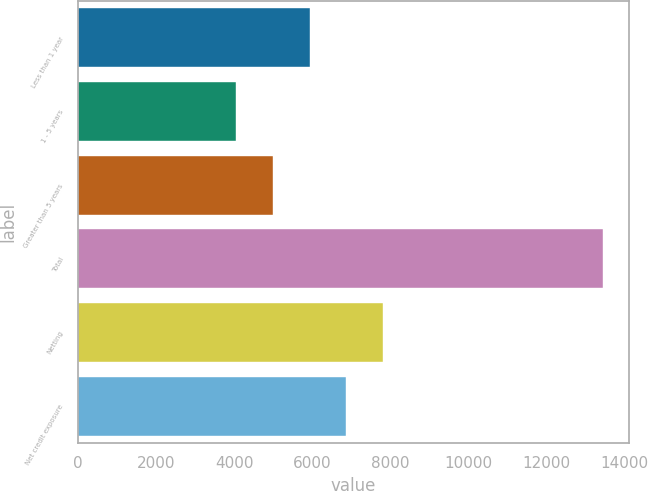Convert chart. <chart><loc_0><loc_0><loc_500><loc_500><bar_chart><fcel>Less than 1 year<fcel>1 - 5 years<fcel>Greater than 5 years<fcel>Total<fcel>Netting<fcel>Net credit exposure<nl><fcel>5931.6<fcel>4053<fcel>4992.3<fcel>13446<fcel>7810.2<fcel>6870.9<nl></chart> 